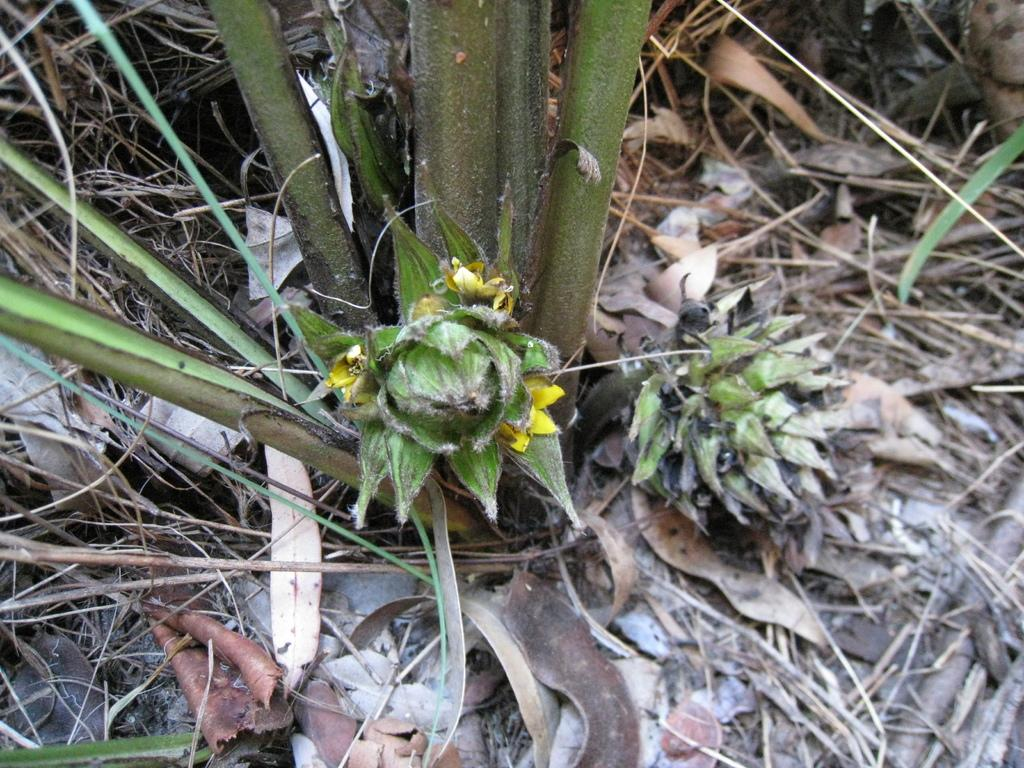What is the main subject of the image? There is a flower in the image. What can be seen surrounding the flower? There are branches surrounding the flower. What type of vegetation is present at the bottom of the image? Dried leaves are present at the bottom of the image. What type of pencil can be seen in the image? There is no pencil present in the image. Is there a train visible in the image? No, there is no train visible in the image. 